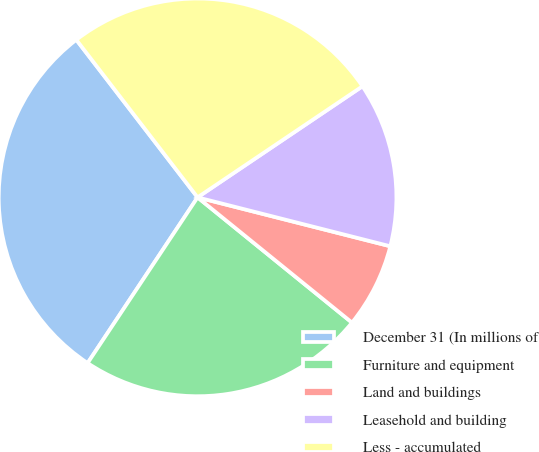Convert chart to OTSL. <chart><loc_0><loc_0><loc_500><loc_500><pie_chart><fcel>December 31 (In millions of<fcel>Furniture and equipment<fcel>Land and buildings<fcel>Leasehold and building<fcel>Less - accumulated<nl><fcel>30.24%<fcel>23.48%<fcel>6.89%<fcel>13.39%<fcel>26.0%<nl></chart> 